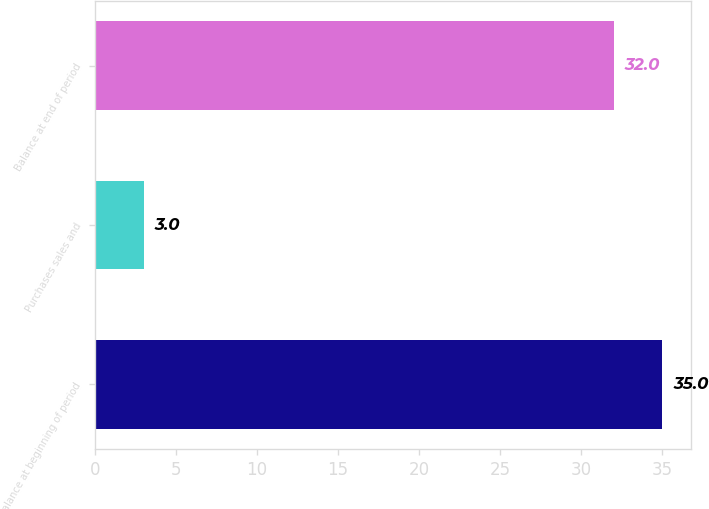Convert chart. <chart><loc_0><loc_0><loc_500><loc_500><bar_chart><fcel>Balance at beginning of period<fcel>Purchases sales and<fcel>Balance at end of period<nl><fcel>35<fcel>3<fcel>32<nl></chart> 